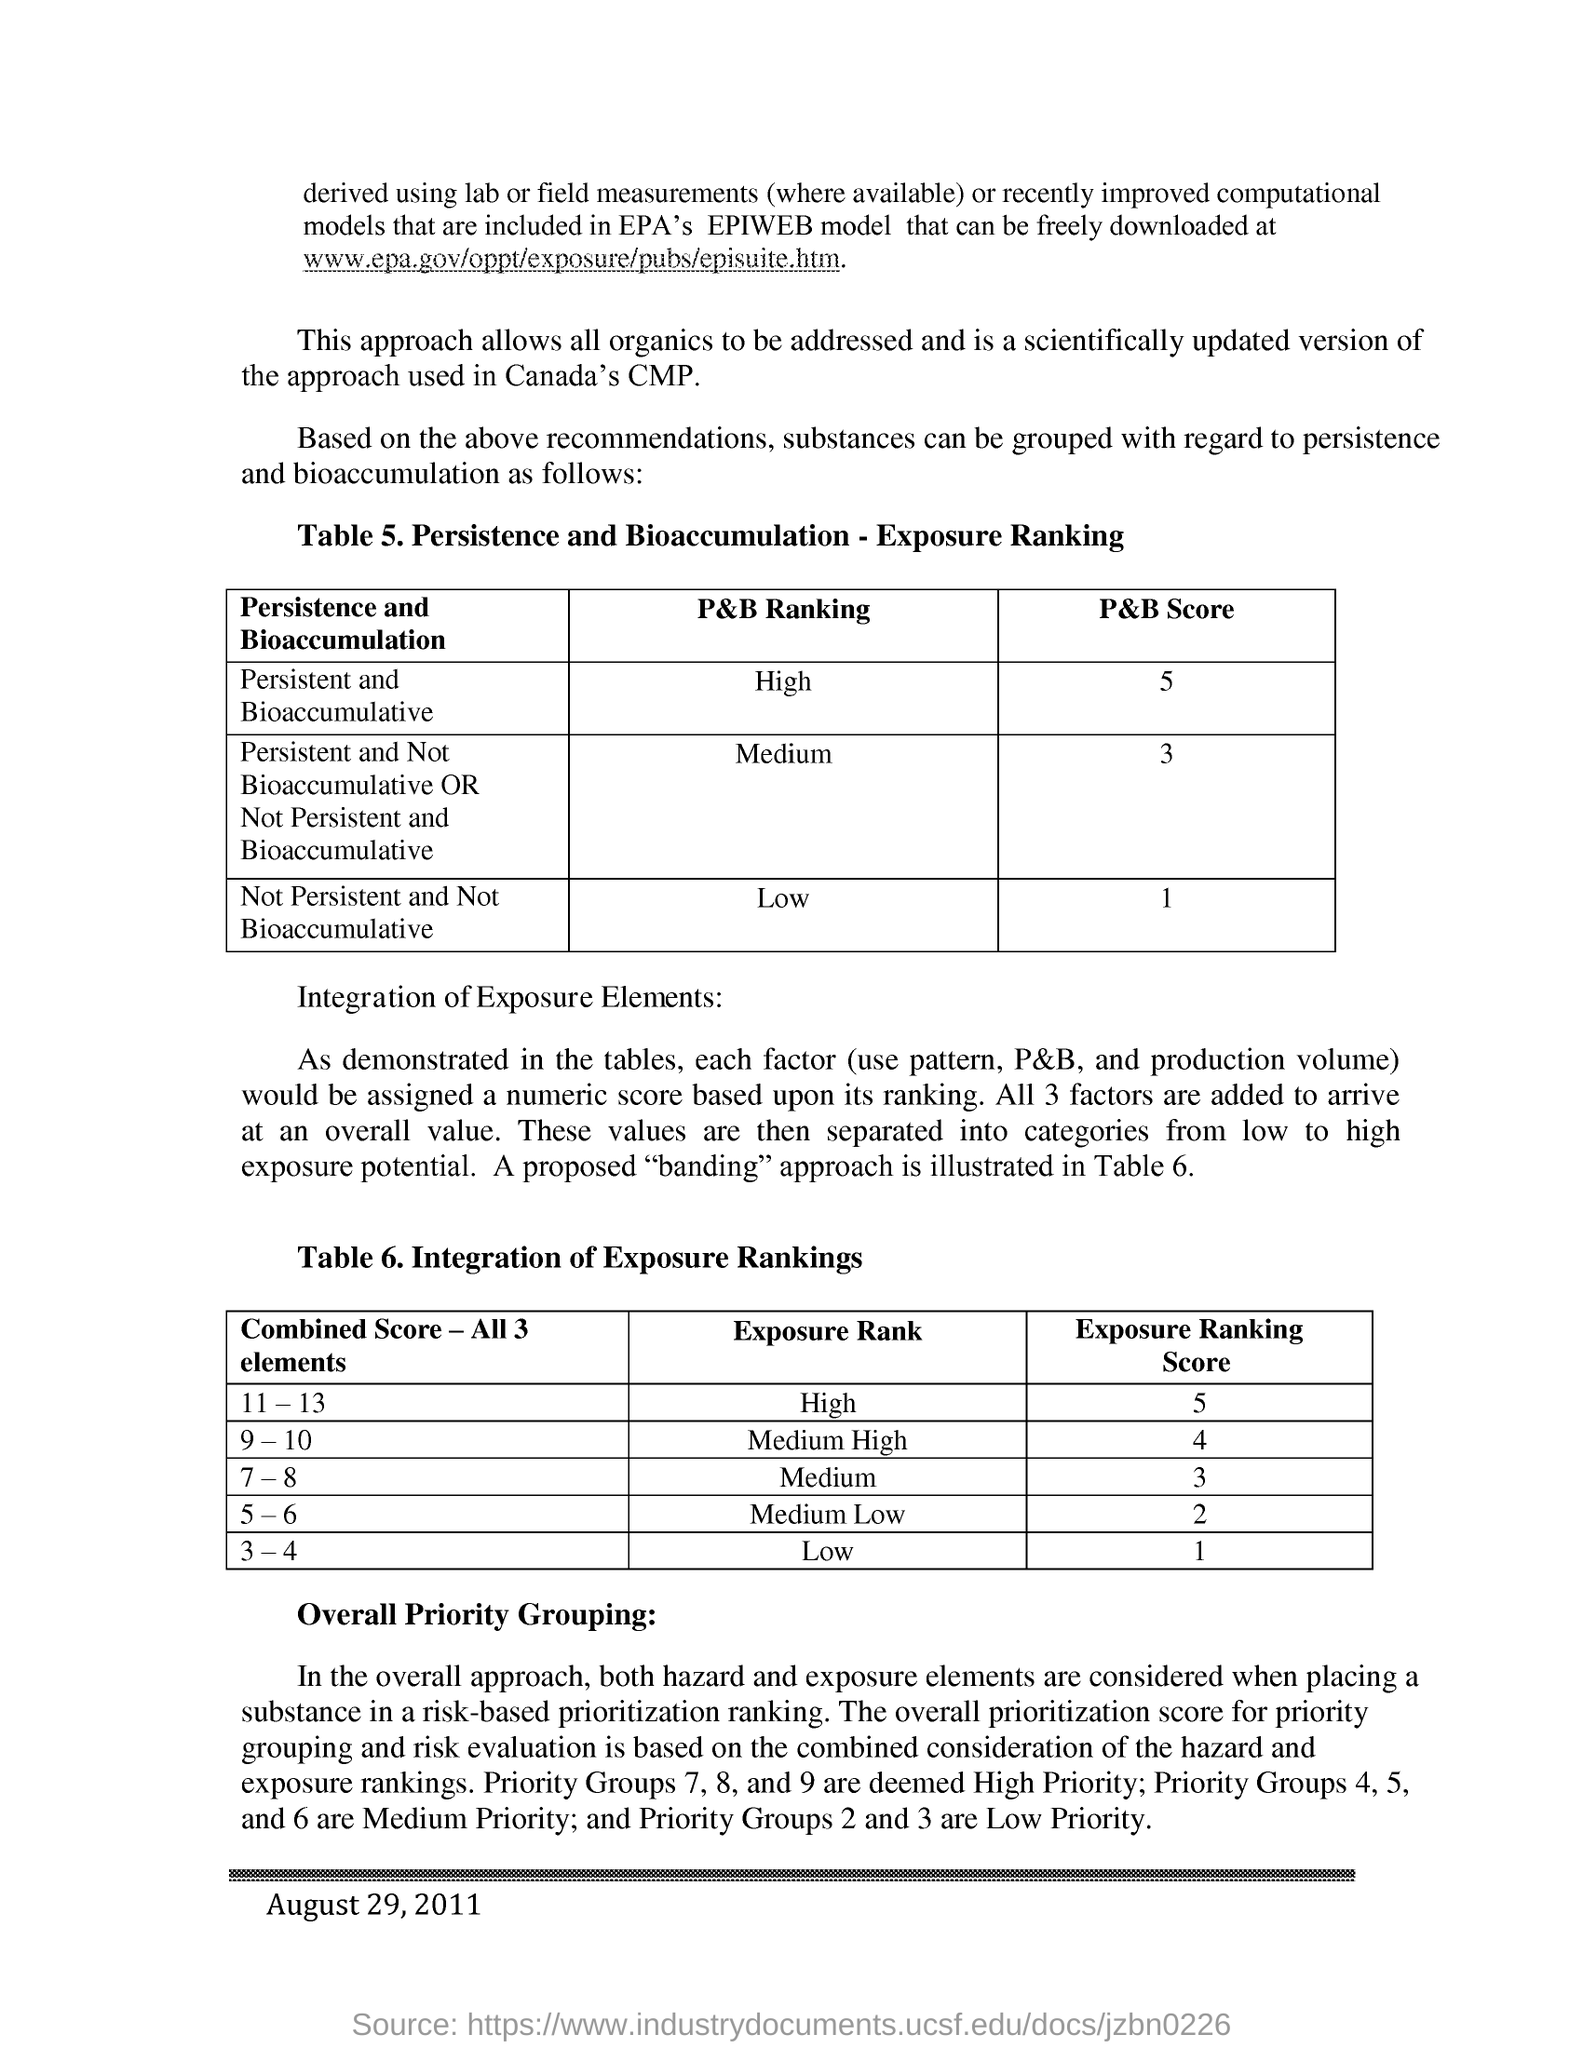Identify some key points in this picture. The data was published in the year 2011. The combined score for all three elements was 11-13, which indicates a high exposure rank. Priority groups 4, 5, and 6 are considered medium priority groups. Low priority groups are defined as those in priority groups 2 and 3. According to the Persistent and Bioaccumulative (P&B) ranking, chemicals that are not persistent and not bioaccumulative are considered low in terms of their environmental impact. 